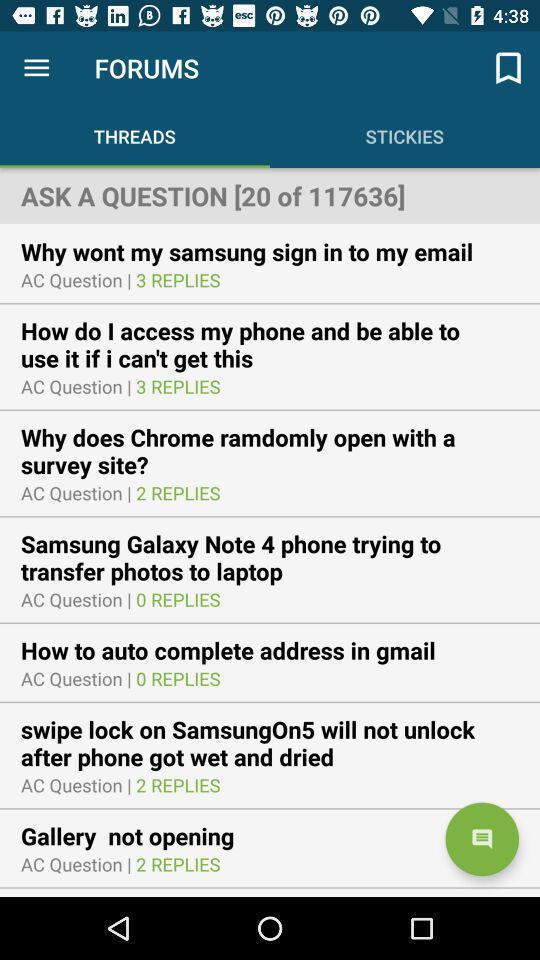Describe the content in this image. Screen showing list of question threads of social app. 